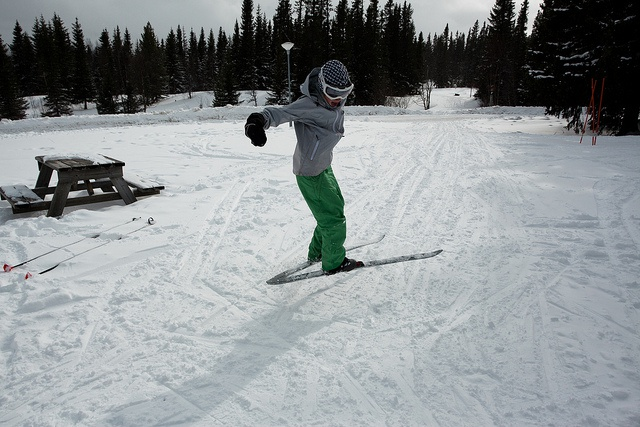Describe the objects in this image and their specific colors. I can see people in gray, black, darkgreen, and teal tones, bench in gray, black, lightgray, and darkgray tones, bench in gray, black, lightgray, and darkgray tones, skis in gray, lightgray, and darkgray tones, and skis in gray, darkgray, and lightgray tones in this image. 